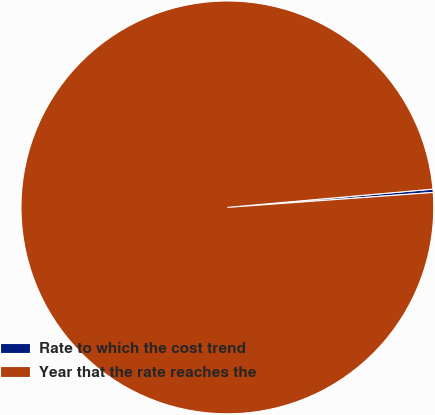Convert chart. <chart><loc_0><loc_0><loc_500><loc_500><pie_chart><fcel>Rate to which the cost trend<fcel>Year that the rate reaches the<nl><fcel>0.26%<fcel>99.74%<nl></chart> 